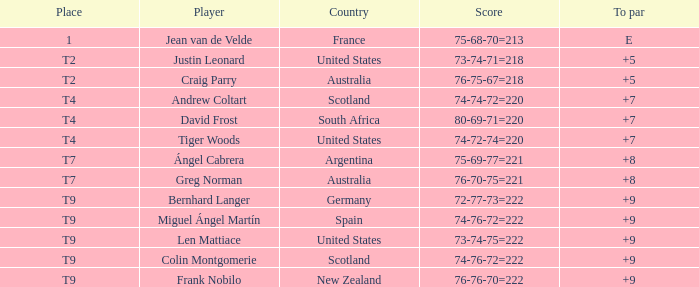For the match in which player David Frost scored a To Par of +7, what was the final score? 80-69-71=220. 